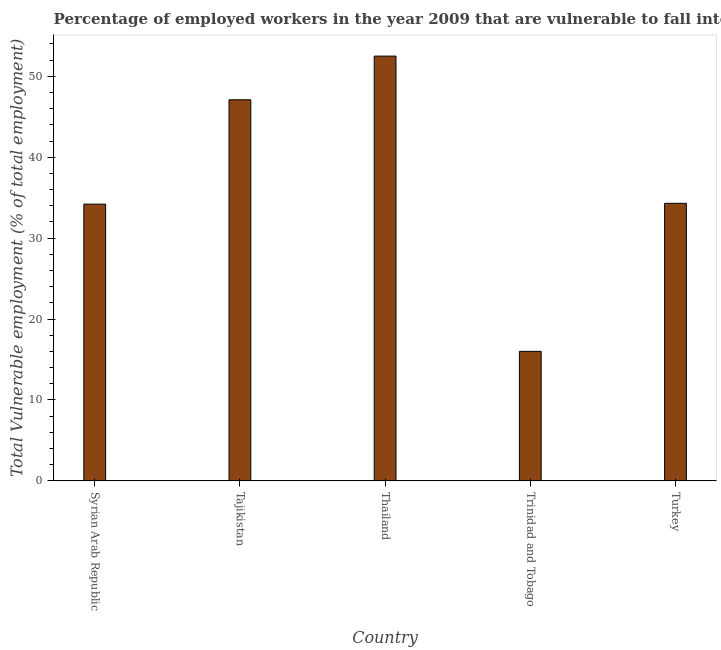Does the graph contain any zero values?
Provide a succinct answer. No. Does the graph contain grids?
Your response must be concise. No. What is the title of the graph?
Your response must be concise. Percentage of employed workers in the year 2009 that are vulnerable to fall into poverty. What is the label or title of the X-axis?
Make the answer very short. Country. What is the label or title of the Y-axis?
Ensure brevity in your answer.  Total Vulnerable employment (% of total employment). What is the total vulnerable employment in Tajikistan?
Make the answer very short. 47.1. Across all countries, what is the maximum total vulnerable employment?
Offer a terse response. 52.5. In which country was the total vulnerable employment maximum?
Keep it short and to the point. Thailand. In which country was the total vulnerable employment minimum?
Give a very brief answer. Trinidad and Tobago. What is the sum of the total vulnerable employment?
Make the answer very short. 184.1. What is the difference between the total vulnerable employment in Tajikistan and Trinidad and Tobago?
Make the answer very short. 31.1. What is the average total vulnerable employment per country?
Offer a terse response. 36.82. What is the median total vulnerable employment?
Your answer should be compact. 34.3. What is the ratio of the total vulnerable employment in Tajikistan to that in Thailand?
Provide a short and direct response. 0.9. Is the difference between the total vulnerable employment in Trinidad and Tobago and Turkey greater than the difference between any two countries?
Ensure brevity in your answer.  No. What is the difference between the highest and the lowest total vulnerable employment?
Provide a short and direct response. 36.5. What is the Total Vulnerable employment (% of total employment) in Syrian Arab Republic?
Give a very brief answer. 34.2. What is the Total Vulnerable employment (% of total employment) in Tajikistan?
Your answer should be compact. 47.1. What is the Total Vulnerable employment (% of total employment) in Thailand?
Your answer should be compact. 52.5. What is the Total Vulnerable employment (% of total employment) in Turkey?
Provide a succinct answer. 34.3. What is the difference between the Total Vulnerable employment (% of total employment) in Syrian Arab Republic and Thailand?
Give a very brief answer. -18.3. What is the difference between the Total Vulnerable employment (% of total employment) in Syrian Arab Republic and Trinidad and Tobago?
Make the answer very short. 18.2. What is the difference between the Total Vulnerable employment (% of total employment) in Tajikistan and Trinidad and Tobago?
Your answer should be very brief. 31.1. What is the difference between the Total Vulnerable employment (% of total employment) in Tajikistan and Turkey?
Provide a short and direct response. 12.8. What is the difference between the Total Vulnerable employment (% of total employment) in Thailand and Trinidad and Tobago?
Ensure brevity in your answer.  36.5. What is the difference between the Total Vulnerable employment (% of total employment) in Thailand and Turkey?
Give a very brief answer. 18.2. What is the difference between the Total Vulnerable employment (% of total employment) in Trinidad and Tobago and Turkey?
Your answer should be compact. -18.3. What is the ratio of the Total Vulnerable employment (% of total employment) in Syrian Arab Republic to that in Tajikistan?
Your answer should be very brief. 0.73. What is the ratio of the Total Vulnerable employment (% of total employment) in Syrian Arab Republic to that in Thailand?
Provide a short and direct response. 0.65. What is the ratio of the Total Vulnerable employment (% of total employment) in Syrian Arab Republic to that in Trinidad and Tobago?
Give a very brief answer. 2.14. What is the ratio of the Total Vulnerable employment (% of total employment) in Syrian Arab Republic to that in Turkey?
Your response must be concise. 1. What is the ratio of the Total Vulnerable employment (% of total employment) in Tajikistan to that in Thailand?
Provide a short and direct response. 0.9. What is the ratio of the Total Vulnerable employment (% of total employment) in Tajikistan to that in Trinidad and Tobago?
Your answer should be very brief. 2.94. What is the ratio of the Total Vulnerable employment (% of total employment) in Tajikistan to that in Turkey?
Keep it short and to the point. 1.37. What is the ratio of the Total Vulnerable employment (% of total employment) in Thailand to that in Trinidad and Tobago?
Give a very brief answer. 3.28. What is the ratio of the Total Vulnerable employment (% of total employment) in Thailand to that in Turkey?
Your answer should be compact. 1.53. What is the ratio of the Total Vulnerable employment (% of total employment) in Trinidad and Tobago to that in Turkey?
Your answer should be very brief. 0.47. 